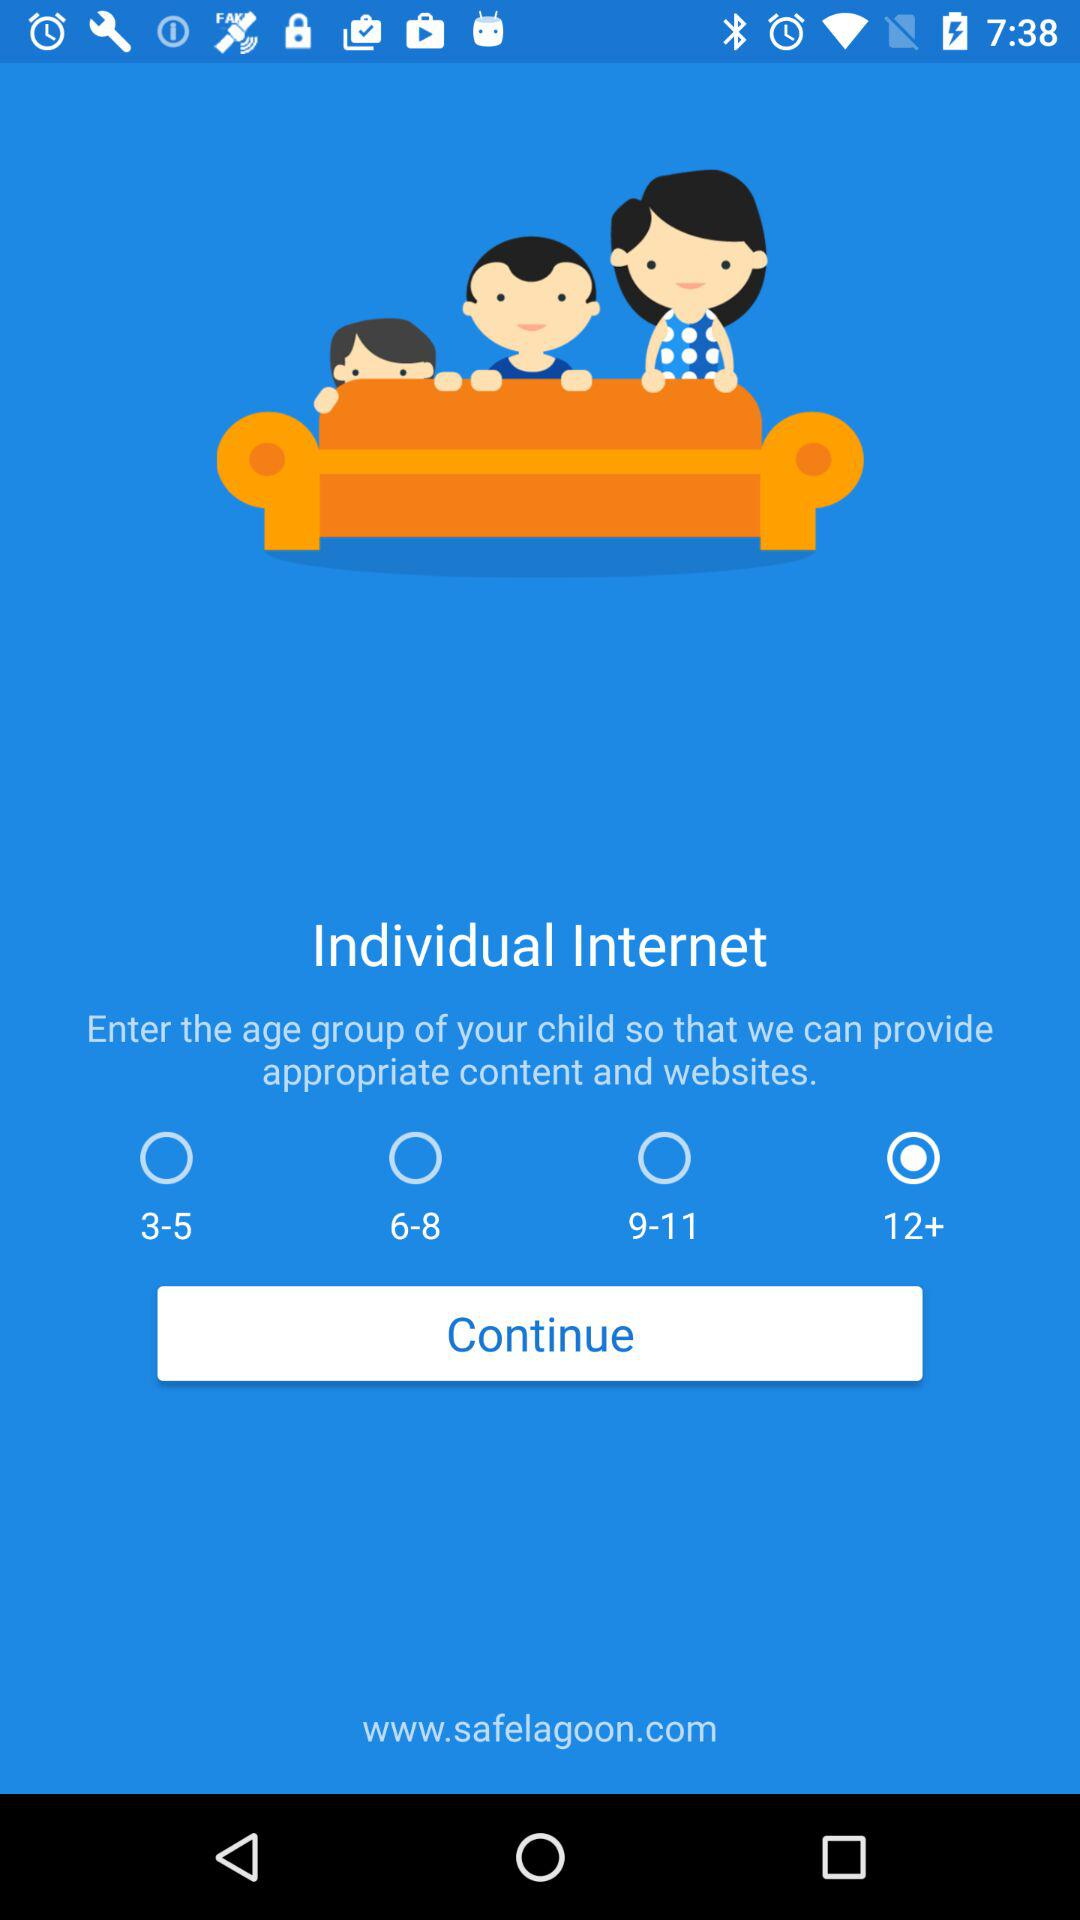Which age group was selected? The selected age group was 12+. 